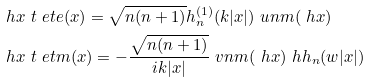<formula> <loc_0><loc_0><loc_500><loc_500>& \ h { x } \ t \ e t e ( x ) = \sqrt { n ( n + 1 ) } h _ { n } ^ { ( 1 ) } ( k | x | ) \ u n m ( \ h { x } ) \\ & \ h { x } \ t \ e t m ( x ) = - \frac { \sqrt { n ( n + 1 ) } } { i k | x | } \ v n m ( \ h { x } ) \ h h _ { n } ( w | x | )</formula> 